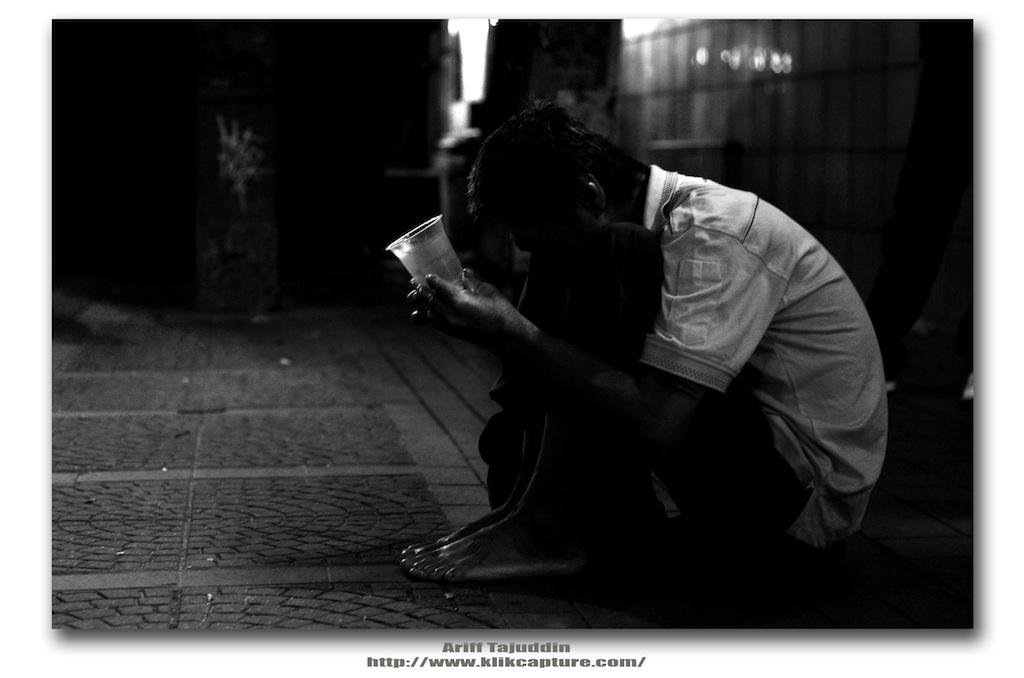What is the person in the image doing? The person is sitting on the floor in the image. What object is the person holding? The person is holding a glass. What color is the background of the image? The background of the image is black. Is the image in color or black and white? The image is in black and white. Can you see any waves in the image? There are no waves present in the image; it features a person sitting on the floor with a black background. 